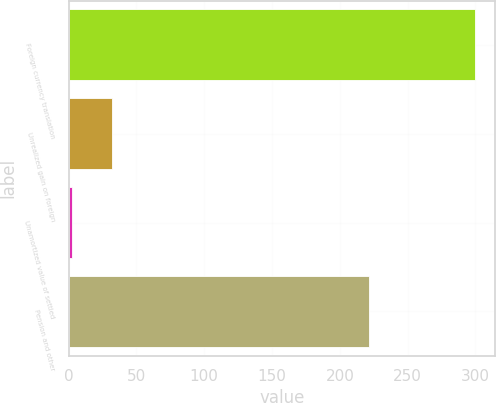Convert chart. <chart><loc_0><loc_0><loc_500><loc_500><bar_chart><fcel>Foreign currency translation<fcel>Unrealized gain on foreign<fcel>Unamortized value of settled<fcel>Pension and other<nl><fcel>299.4<fcel>32.1<fcel>2.4<fcel>221.3<nl></chart> 